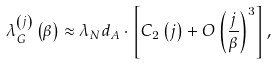Convert formula to latex. <formula><loc_0><loc_0><loc_500><loc_500>\lambda _ { G } ^ { \left ( j \right ) } \left ( \beta \right ) \approx \lambda _ { N } d _ { A } \cdot \left [ C _ { 2 } \left ( j \right ) + O \left ( \frac { j } { \beta } \right ) ^ { 3 } \right ] ,</formula> 